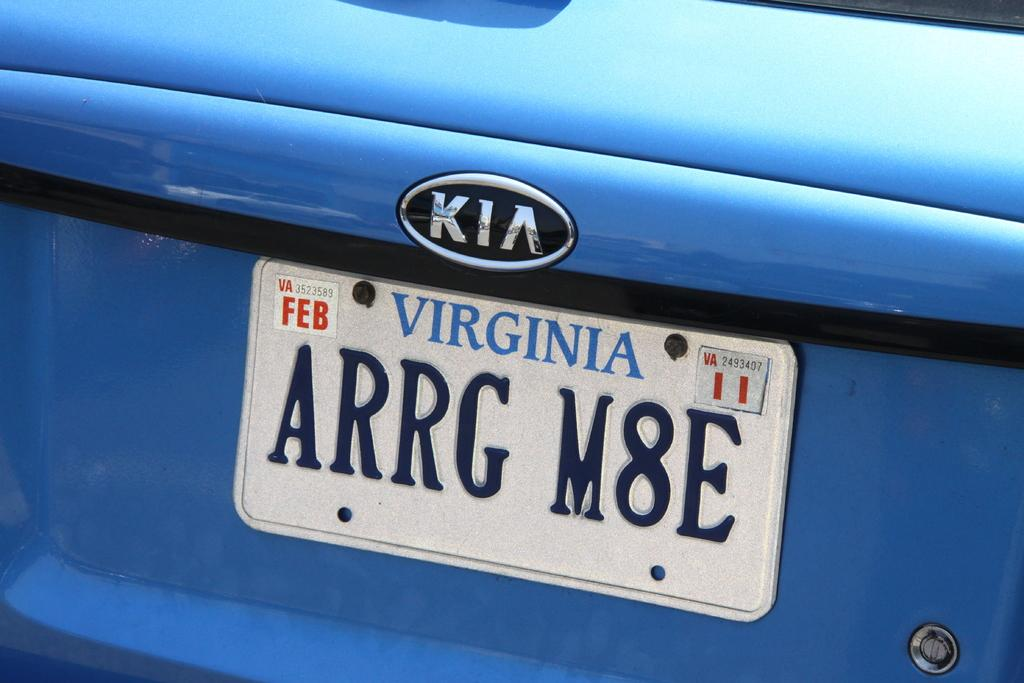<image>
Render a clear and concise summary of the photo. A Kia car from VIRGINIA with license plate ARRG M8E. 